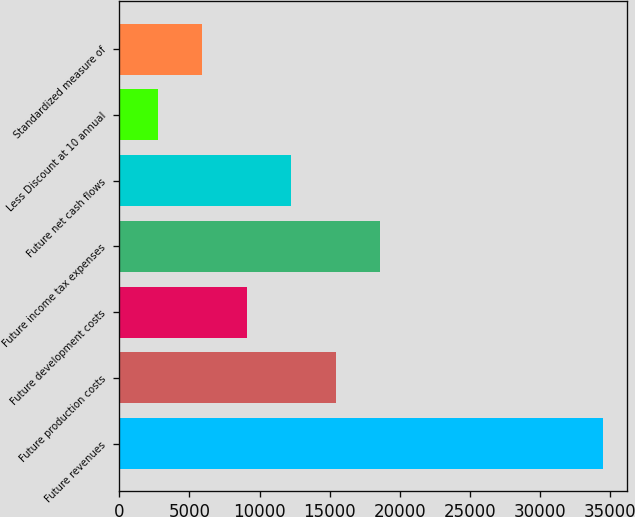<chart> <loc_0><loc_0><loc_500><loc_500><bar_chart><fcel>Future revenues<fcel>Future production costs<fcel>Future development costs<fcel>Future income tax expenses<fcel>Future net cash flows<fcel>Less Discount at 10 annual<fcel>Standardized measure of<nl><fcel>34495<fcel>15451<fcel>9103<fcel>18625<fcel>12277<fcel>2755<fcel>5929<nl></chart> 